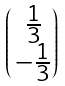<formula> <loc_0><loc_0><loc_500><loc_500>\begin{pmatrix} \, \frac { 1 } { 3 } \\ \, - \frac { 1 } { 3 } \end{pmatrix}</formula> 